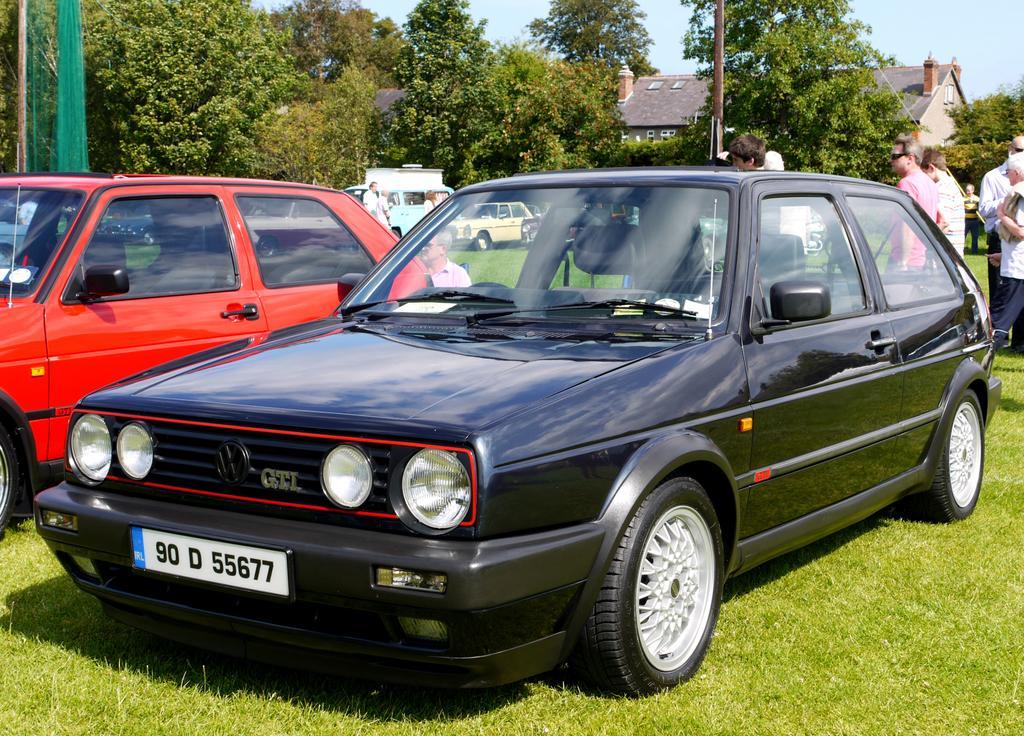How would you summarize this image in a sentence or two? In the middle of this image, there are vehicles in different colors and persons on the ground, on which there is grass. In the background, there are trees, a building and there is sky. 